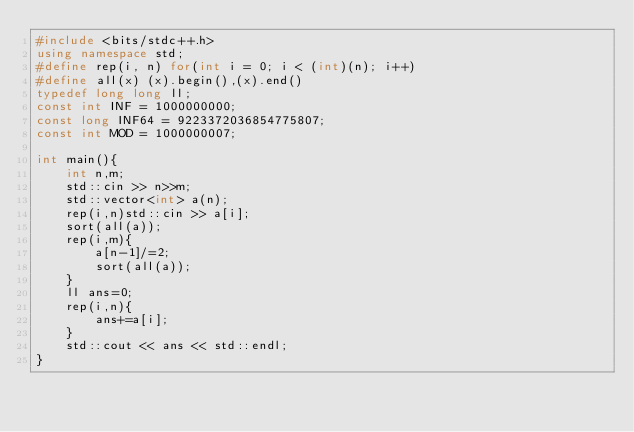Convert code to text. <code><loc_0><loc_0><loc_500><loc_500><_C++_>#include <bits/stdc++.h>
using namespace std;
#define rep(i, n) for(int i = 0; i < (int)(n); i++)
#define all(x) (x).begin(),(x).end()
typedef long long ll;
const int INF = 1000000000;
const long INF64 = 9223372036854775807;
const int MOD = 1000000007;

int main(){
	int n,m;
	std::cin >> n>>m;
	std::vector<int> a(n);
	rep(i,n)std::cin >> a[i];
	sort(all(a));
	rep(i,m){
		a[n-1]/=2;
		sort(all(a));
	}
	ll ans=0;
	rep(i,n){
		ans+=a[i];
	}
	std::cout << ans << std::endl;
}</code> 